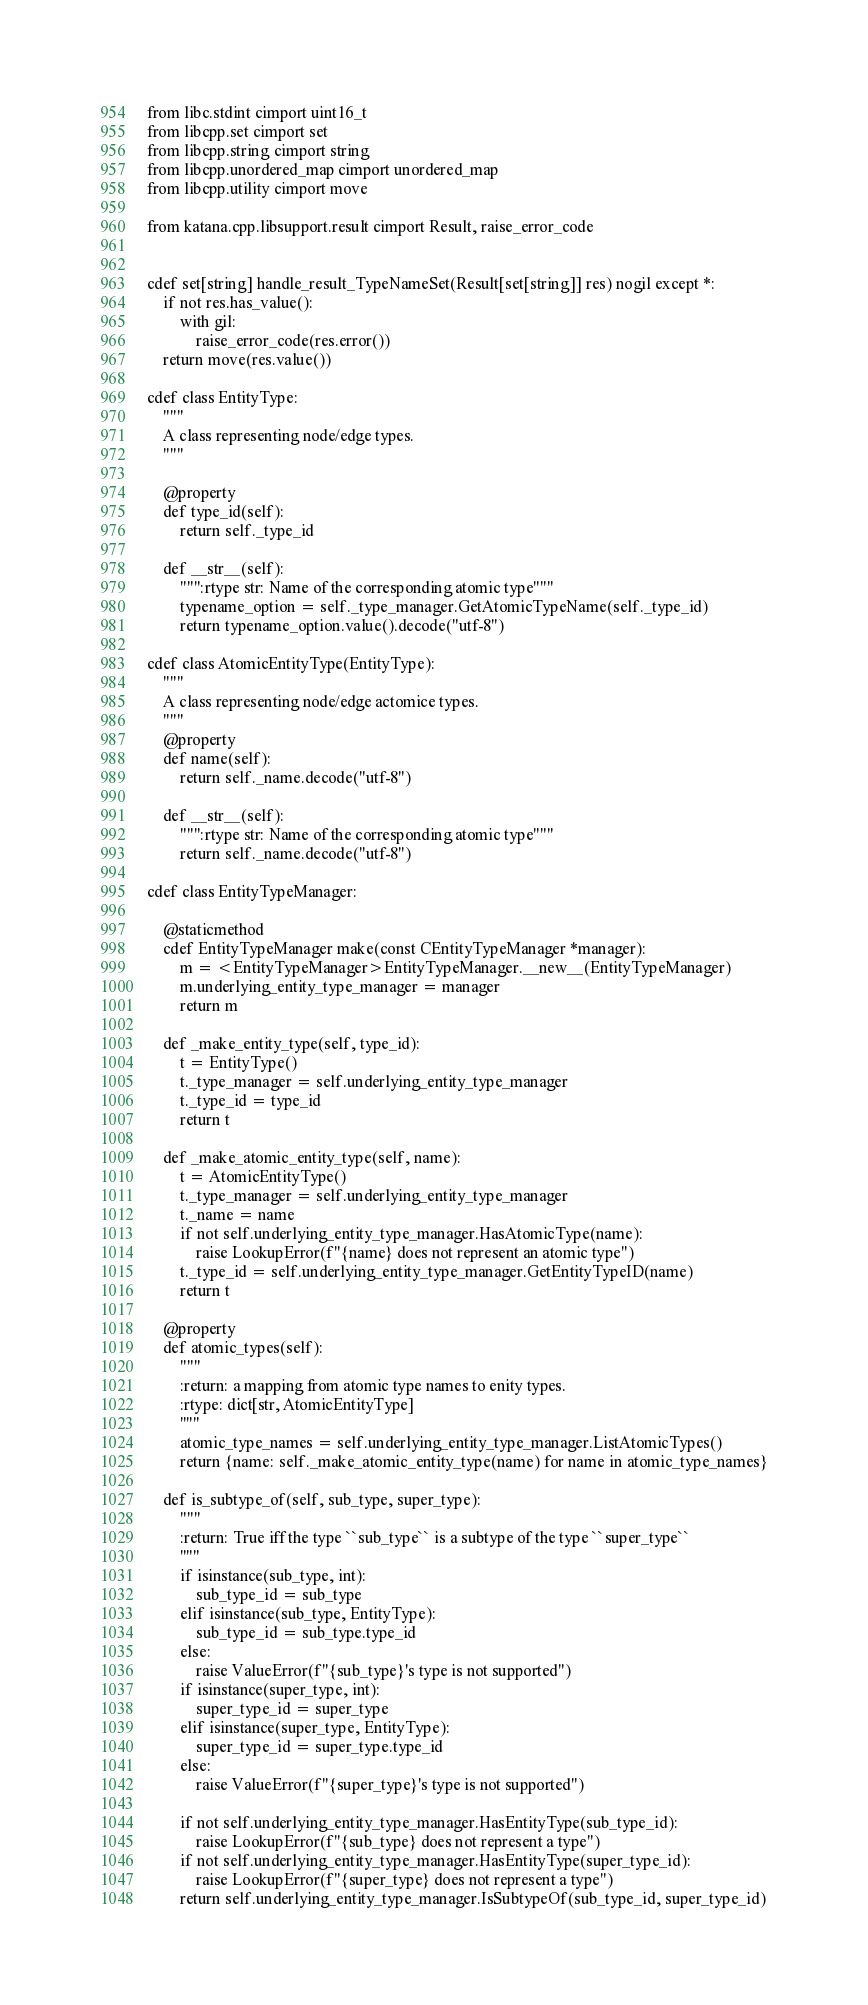Convert code to text. <code><loc_0><loc_0><loc_500><loc_500><_Cython_>from libc.stdint cimport uint16_t
from libcpp.set cimport set
from libcpp.string cimport string
from libcpp.unordered_map cimport unordered_map
from libcpp.utility cimport move

from katana.cpp.libsupport.result cimport Result, raise_error_code


cdef set[string] handle_result_TypeNameSet(Result[set[string]] res) nogil except *:
    if not res.has_value():
        with gil:
            raise_error_code(res.error())
    return move(res.value())

cdef class EntityType:
    """
    A class representing node/edge types.
    """

    @property
    def type_id(self):
        return self._type_id

    def __str__(self):
        """:rtype str: Name of the corresponding atomic type"""
        typename_option = self._type_manager.GetAtomicTypeName(self._type_id)
        return typename_option.value().decode("utf-8")

cdef class AtomicEntityType(EntityType):
    """
    A class representing node/edge actomice types.
    """
    @property
    def name(self):
        return self._name.decode("utf-8")

    def __str__(self):
        """:rtype str: Name of the corresponding atomic type"""
        return self._name.decode("utf-8")

cdef class EntityTypeManager:

    @staticmethod
    cdef EntityTypeManager make(const CEntityTypeManager *manager):
        m = <EntityTypeManager>EntityTypeManager.__new__(EntityTypeManager)
        m.underlying_entity_type_manager = manager
        return m

    def _make_entity_type(self, type_id):
        t = EntityType()
        t._type_manager = self.underlying_entity_type_manager
        t._type_id = type_id
        return t

    def _make_atomic_entity_type(self, name):
        t = AtomicEntityType()
        t._type_manager = self.underlying_entity_type_manager
        t._name = name
        if not self.underlying_entity_type_manager.HasAtomicType(name):
            raise LookupError(f"{name} does not represent an atomic type")
        t._type_id = self.underlying_entity_type_manager.GetEntityTypeID(name)
        return t

    @property
    def atomic_types(self):
        """
        :return: a mapping from atomic type names to enity types.
        :rtype: dict[str, AtomicEntityType]
        """
        atomic_type_names = self.underlying_entity_type_manager.ListAtomicTypes()
        return {name: self._make_atomic_entity_type(name) for name in atomic_type_names}

    def is_subtype_of(self, sub_type, super_type):
        """
        :return: True iff the type ``sub_type`` is a subtype of the type ``super_type``
        """
        if isinstance(sub_type, int):
            sub_type_id = sub_type
        elif isinstance(sub_type, EntityType):
            sub_type_id = sub_type.type_id
        else:
            raise ValueError(f"{sub_type}'s type is not supported")
        if isinstance(super_type, int):
            super_type_id = super_type
        elif isinstance(super_type, EntityType):
            super_type_id = super_type.type_id
        else:
            raise ValueError(f"{super_type}'s type is not supported")

        if not self.underlying_entity_type_manager.HasEntityType(sub_type_id):
            raise LookupError(f"{sub_type} does not represent a type")
        if not self.underlying_entity_type_manager.HasEntityType(super_type_id):
            raise LookupError(f"{super_type} does not represent a type")
        return self.underlying_entity_type_manager.IsSubtypeOf(sub_type_id, super_type_id)
</code> 